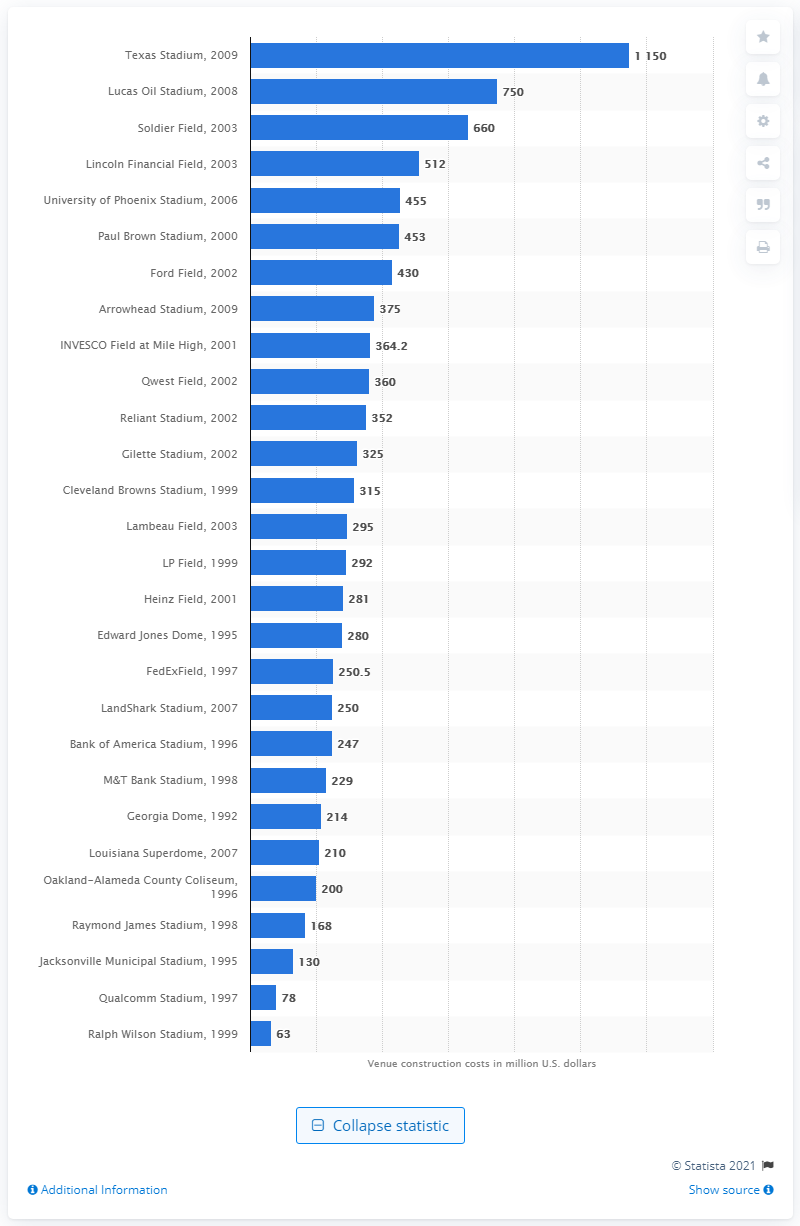Mention a couple of crucial points in this snapshot. The cost of Bank of America Stadium is 247. 